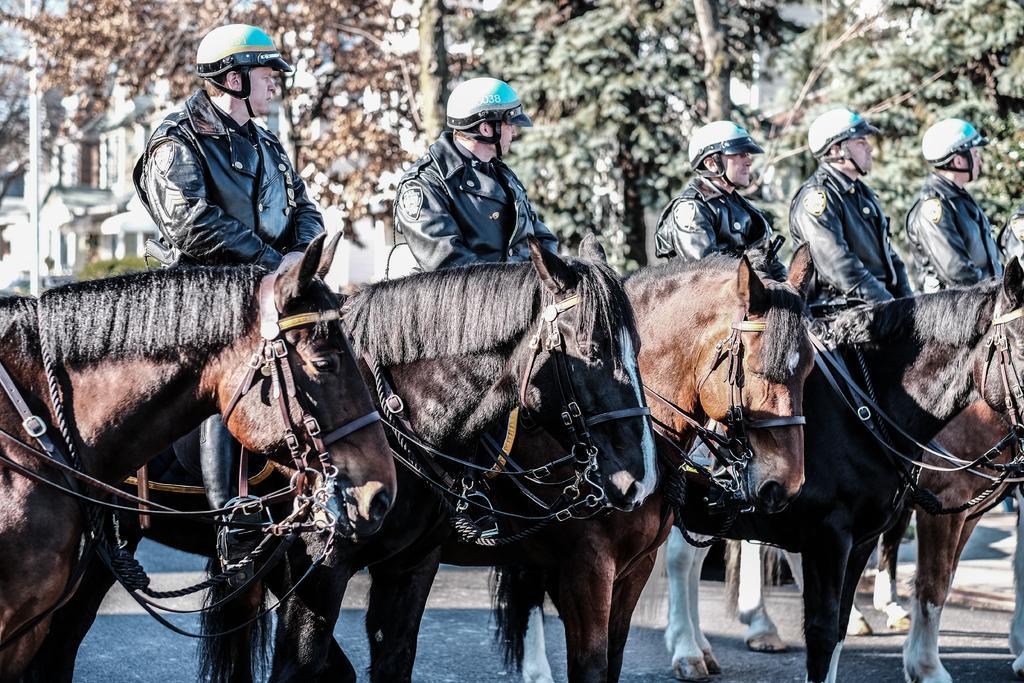How would you summarize this image in a sentence or two? In this image we can see men sitting on the horses and wearing helmets. In the background there are buildings, poles, bushes and trees. 